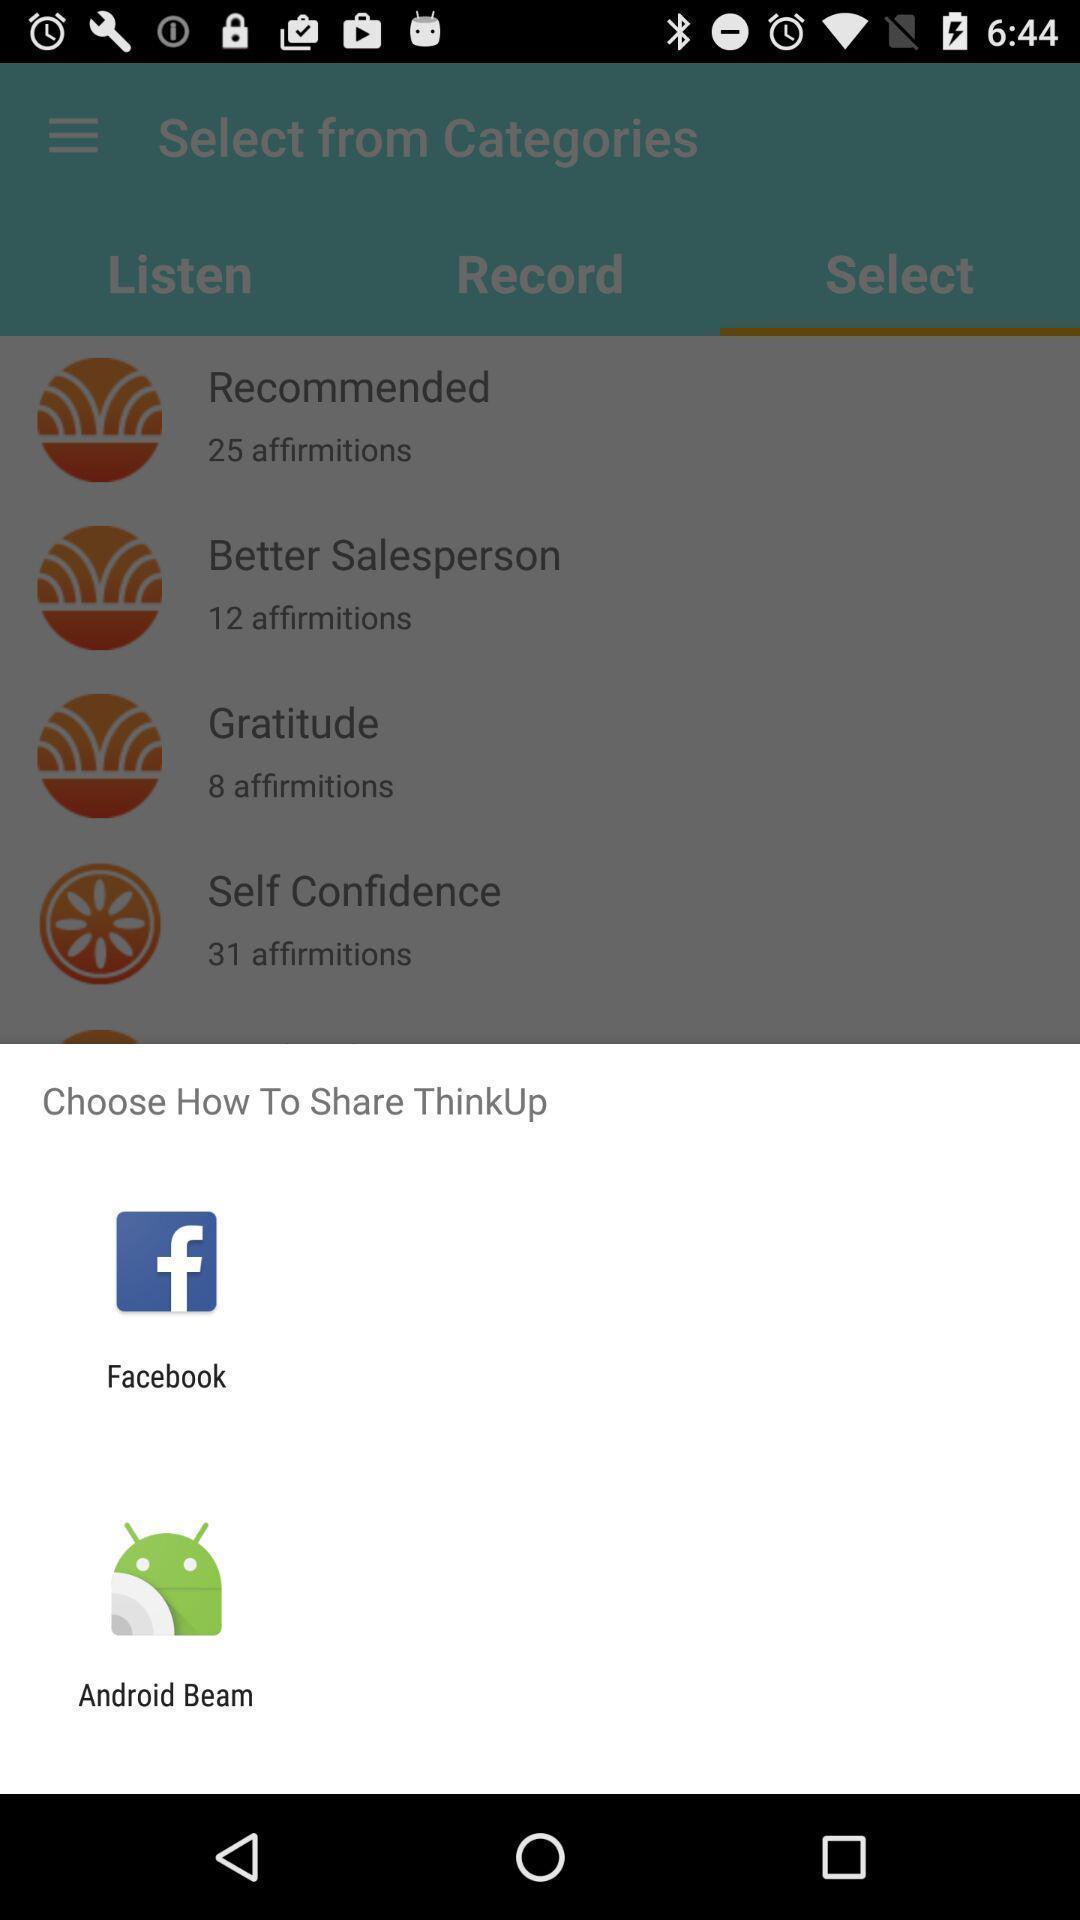What is the overall content of this screenshot? Pop-up showing different sharing options. 